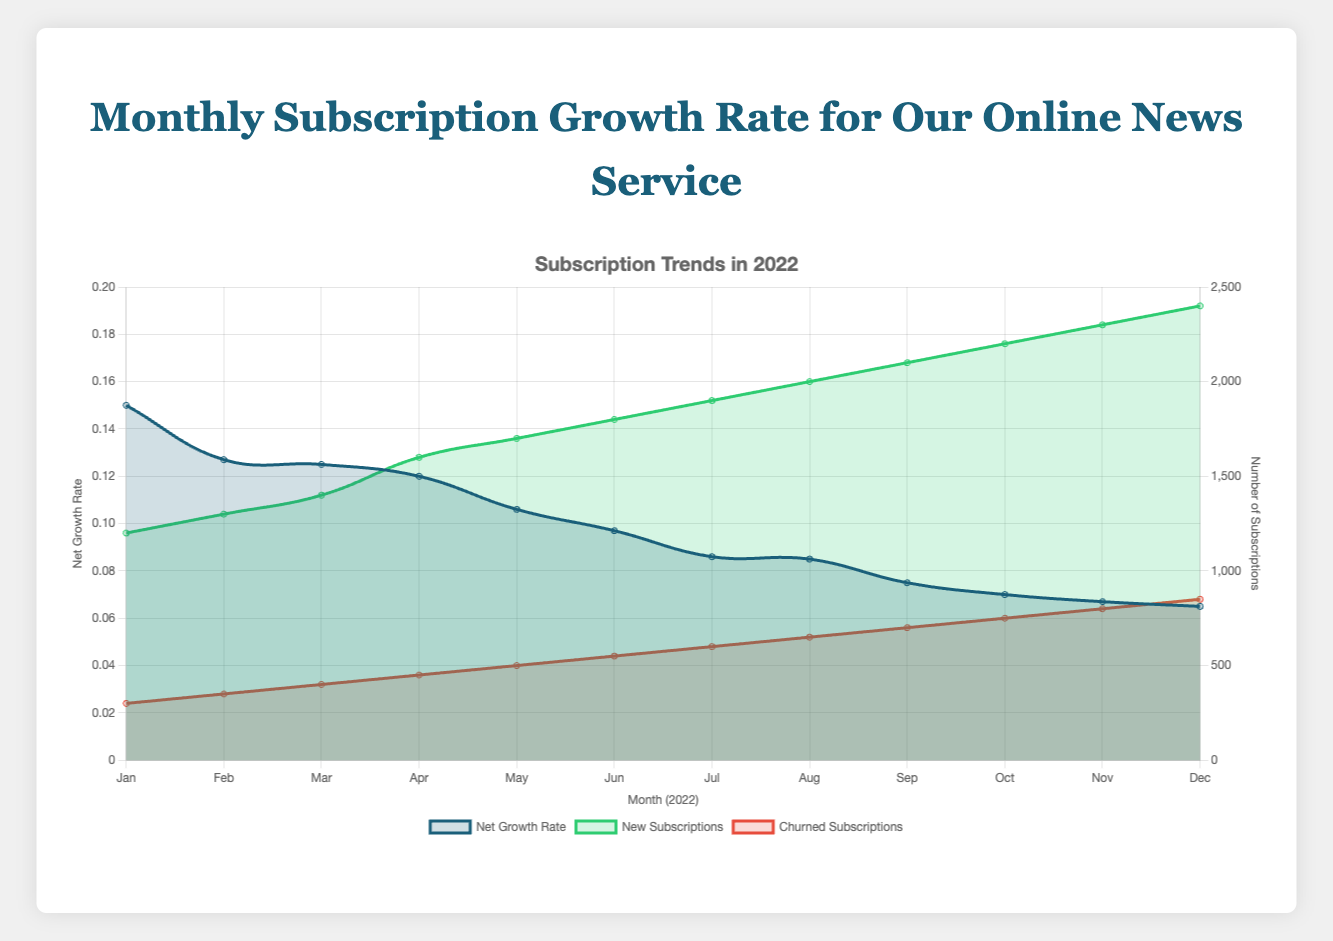What is the net growth rate for January 2022? The net growth rate for January 2022 can be found in the dataset for that month. According to the figure, it's 0.15.
Answer: 0.15 Which month saw the highest number of new subscriptions? By inspecting the green line representing new subscriptions, we can see that December 2022 has the highest new subscriptions, which is 2400.
Answer: December 2022 What is the trend in churned subscriptions throughout 2022? Observing the red line representing churned subscriptions, it's evident that the number of churned subscriptions steadily increased each month, starting from 300 in January to 850 in December.
Answer: Steady increase How does the net growth rate in December 2022 compare to January 2022? The net growth rate in January 2022 was 0.15, whereas in December 2022 it was 0.065. This shows a noticeable decline over the year.
Answer: Decline How did the net growth rate change from June to July 2022? The net growth rate in June was 0.097, and in July it decreased to 0.086. By subtracting July's rate from June's, it's clear there was a drop of 0.011.
Answer: Decrease by 0.011 Which month saw the smallest drop in net growth rate from the previous month? By observing the net growth rate line closely, the smallest drop occurred between July (0.086) and August (0.085), a decrease of just 0.001.
Answer: Between July and August What was the average net growth rate in the first quarter of 2022? The net growth rates for January, February, and March were 0.15, 0.127, and 0.125, respectively. Adding these and dividing by 3 gives (0.15 + 0.127 + 0.125) / 3 = 0.134.
Answer: 0.134 Which month had the most significant decrease in net growth rate compared to its previous month? By examining the net growth rate drops, the largest decrease occurred between April (0.12) and May (0.106), a drop of 0.014 units.
Answer: Between April and May How does the number of churned subscriptions in August compare to February? The number of churned subscriptions in February was 350, and in August, it was 650, showing that August's churned subscriptions were significantly higher by 300.
Answer: Higher by 300 